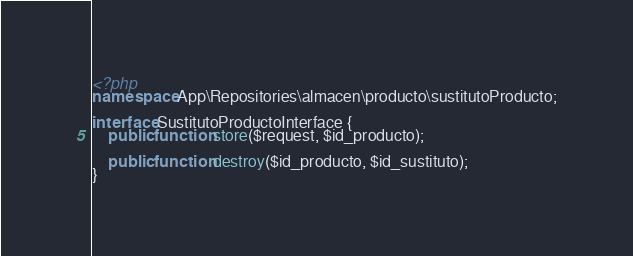<code> <loc_0><loc_0><loc_500><loc_500><_PHP_><?php
namespace App\Repositories\almacen\producto\sustitutoProducto;

interface SustitutoProductoInterface {
    public function store($request, $id_producto);

    public function destroy($id_producto, $id_sustituto);
}</code> 